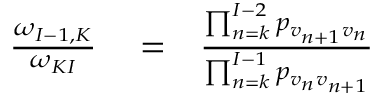Convert formula to latex. <formula><loc_0><loc_0><loc_500><loc_500>\begin{array} { r l r } { { \frac { \omega _ { I - 1 , K } } { \omega _ { K I } } } } & = } & { \frac { \prod _ { n = k } ^ { I - 2 } p _ { v _ { n + 1 } v _ { n } } } { \prod _ { n = k } ^ { I - 1 } p _ { v _ { n } v _ { n + 1 } } } } \end{array}</formula> 